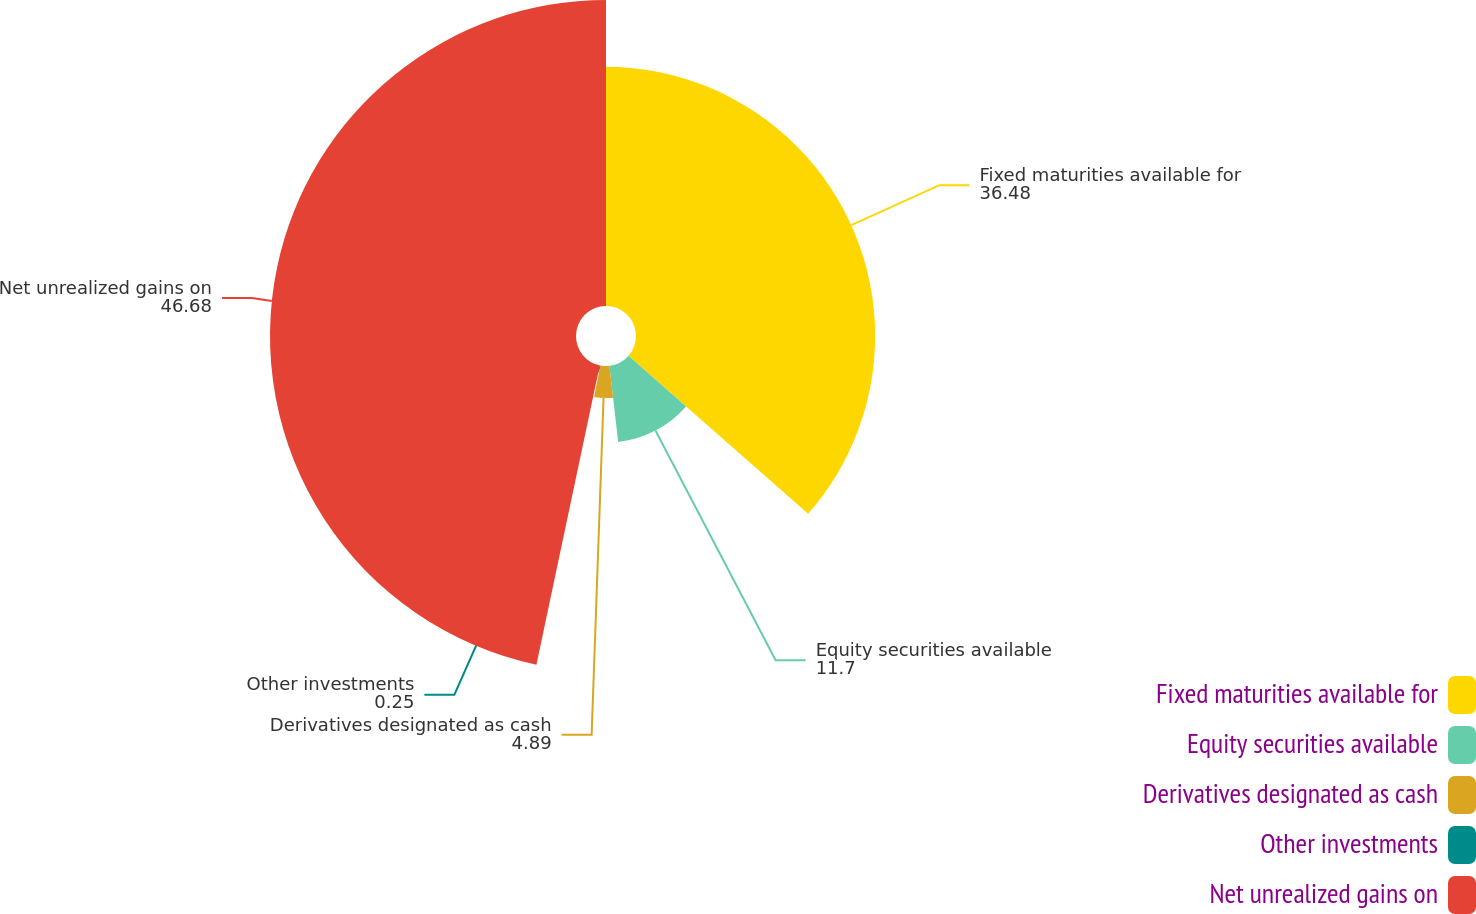<chart> <loc_0><loc_0><loc_500><loc_500><pie_chart><fcel>Fixed maturities available for<fcel>Equity securities available<fcel>Derivatives designated as cash<fcel>Other investments<fcel>Net unrealized gains on<nl><fcel>36.48%<fcel>11.7%<fcel>4.89%<fcel>0.25%<fcel>46.68%<nl></chart> 